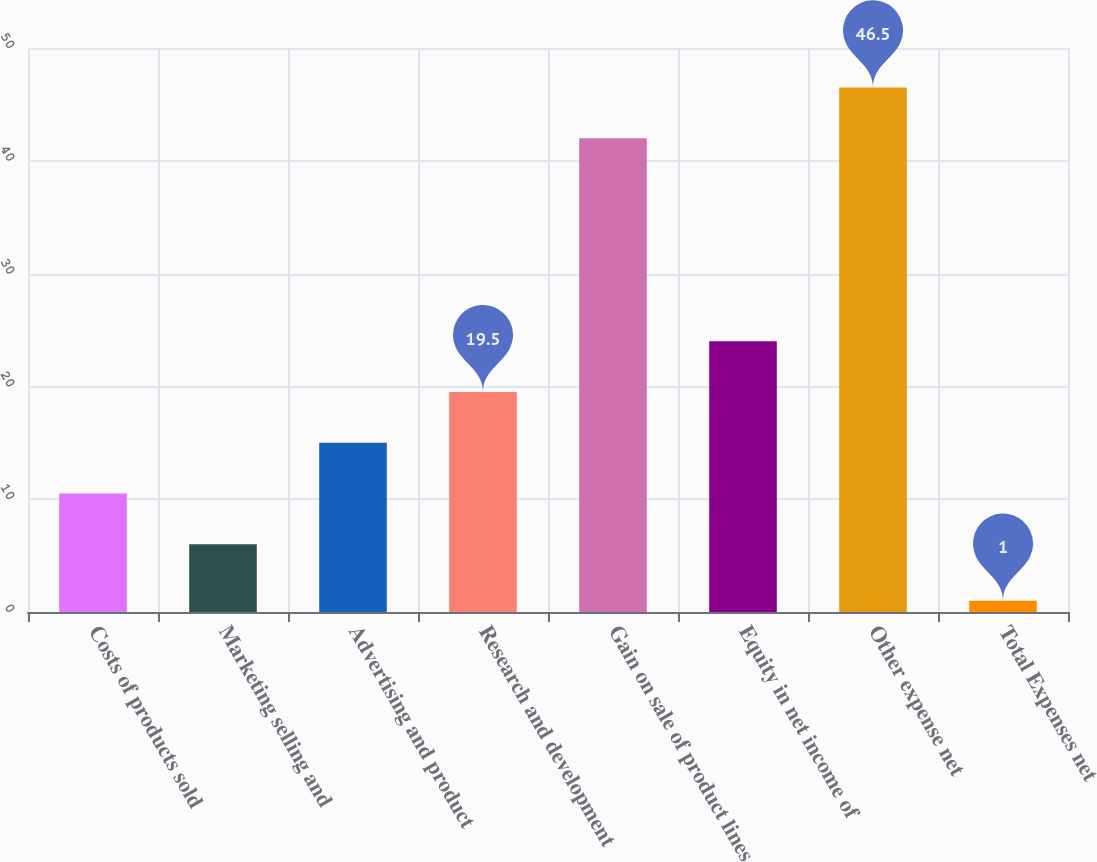Convert chart. <chart><loc_0><loc_0><loc_500><loc_500><bar_chart><fcel>Costs of products sold<fcel>Marketing selling and<fcel>Advertising and product<fcel>Research and development<fcel>Gain on sale of product lines<fcel>Equity in net income of<fcel>Other expense net<fcel>Total Expenses net<nl><fcel>10.5<fcel>6<fcel>15<fcel>19.5<fcel>42<fcel>24<fcel>46.5<fcel>1<nl></chart> 